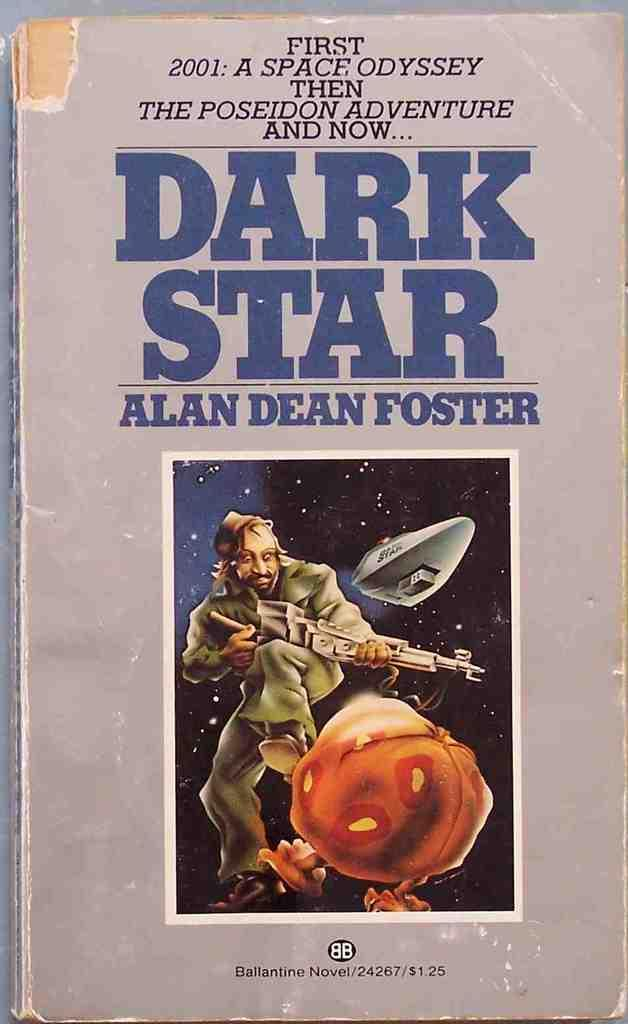<image>
Render a clear and concise summary of the photo. a book cover of DARK STAR by Alan Dean Foster 